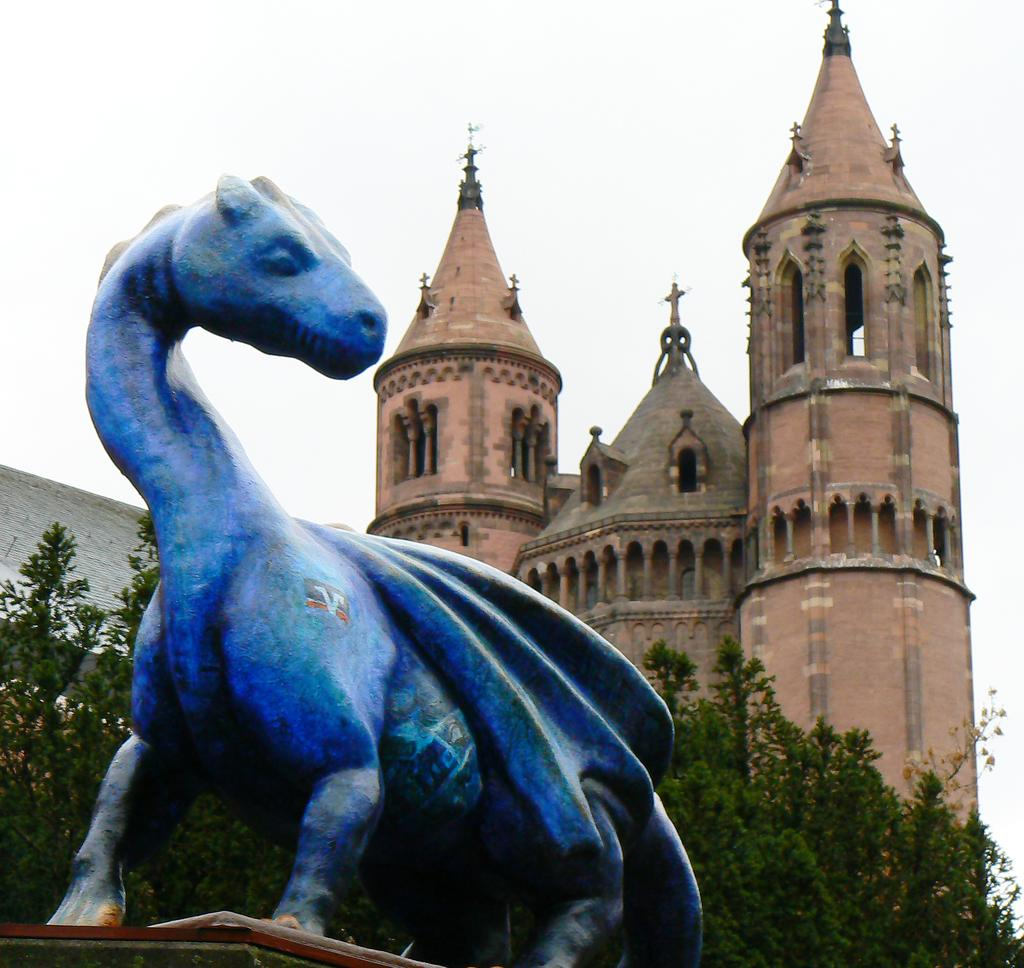What type of structures can be seen in the image? There are buildings in the image. What is located in front of the buildings? Trees are present in front of the buildings. What is the main object in the foreground of the image? There is a sculpture in the foreground of the image. What can be seen at the top of the image? The sky is visible at the top of the image. How many chickens are roaming around the sculpture in the image? There are no chickens present in the image. What type of ticket is required to enter the buildings in the image? There is no mention of tickets or any requirement to enter the buildings in the image. 